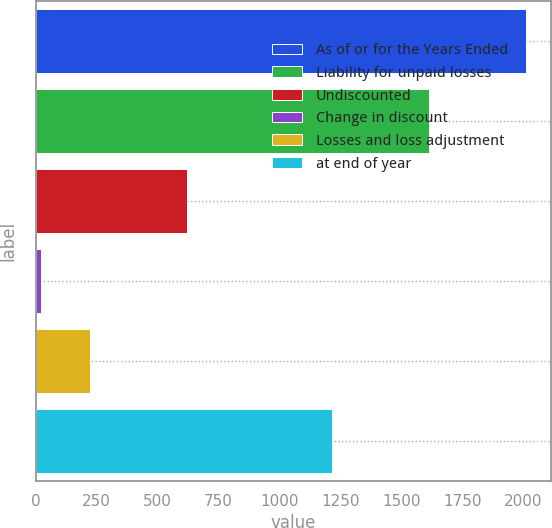Convert chart. <chart><loc_0><loc_0><loc_500><loc_500><bar_chart><fcel>As of or for the Years Ended<fcel>Liability for unpaid losses<fcel>Undiscounted<fcel>Change in discount<fcel>Losses and loss adjustment<fcel>at end of year<nl><fcel>2014<fcel>1615.6<fcel>619.6<fcel>22<fcel>221.2<fcel>1217.2<nl></chart> 